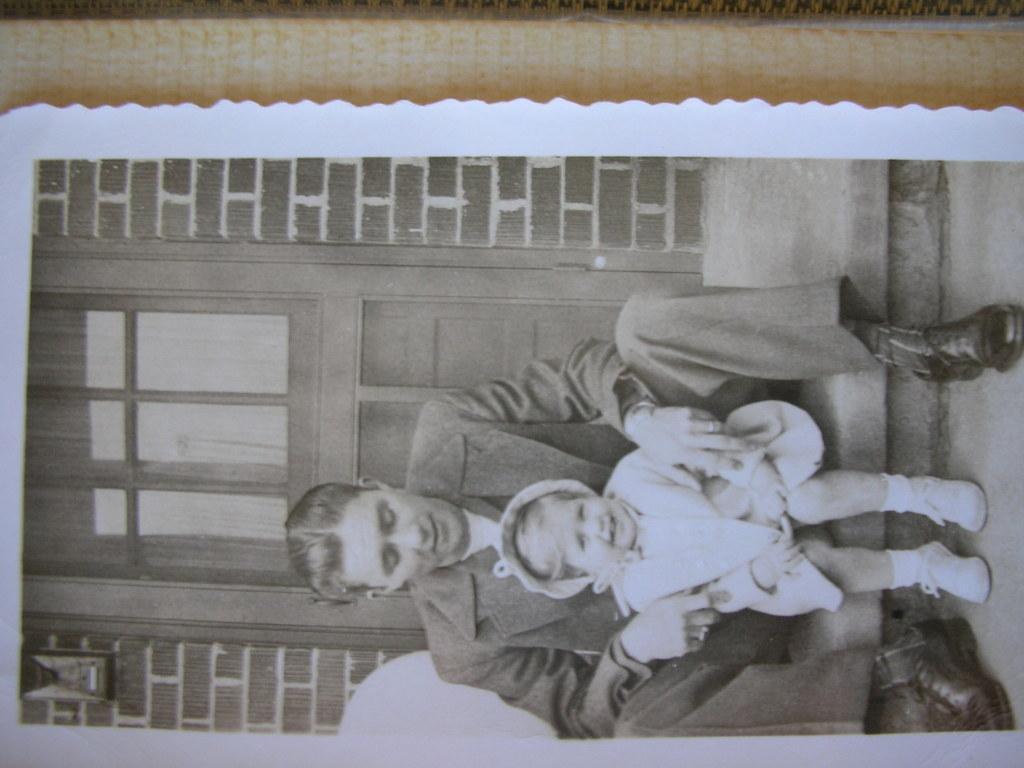Can you describe this image briefly? The picture consists of a photo frame. In the photo there is a man and a kid sitting on staircase, behind them there is a brick wall and door. 